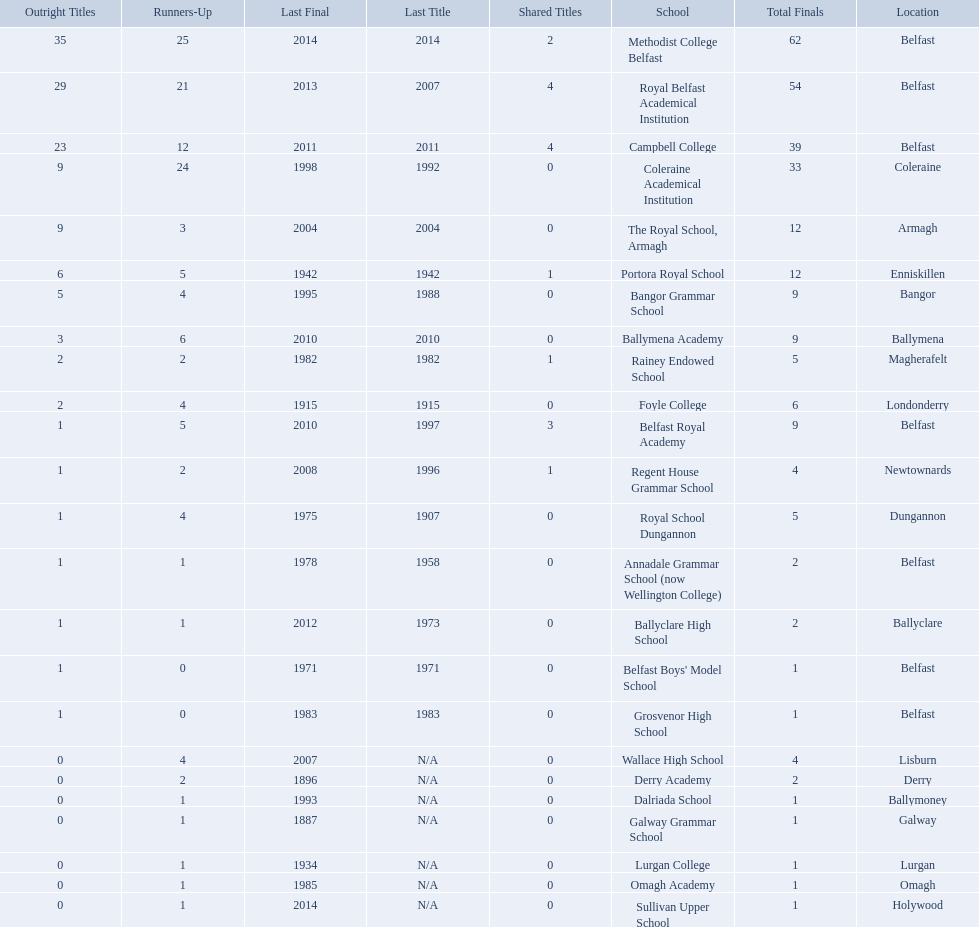Which colleges participated in the ulster's schools' cup? Methodist College Belfast, Royal Belfast Academical Institution, Campbell College, Coleraine Academical Institution, The Royal School, Armagh, Portora Royal School, Bangor Grammar School, Ballymena Academy, Rainey Endowed School, Foyle College, Belfast Royal Academy, Regent House Grammar School, Royal School Dungannon, Annadale Grammar School (now Wellington College), Ballyclare High School, Belfast Boys' Model School, Grosvenor High School, Wallace High School, Derry Academy, Dalriada School, Galway Grammar School, Lurgan College, Omagh Academy, Sullivan Upper School. Of these, which are from belfast? Methodist College Belfast, Royal Belfast Academical Institution, Campbell College, Belfast Royal Academy, Annadale Grammar School (now Wellington College), Belfast Boys' Model School, Grosvenor High School. Of these, which have more than 20 outright titles? Methodist College Belfast, Royal Belfast Academical Institution, Campbell College. Which of these have the fewest runners-up? Campbell College. 